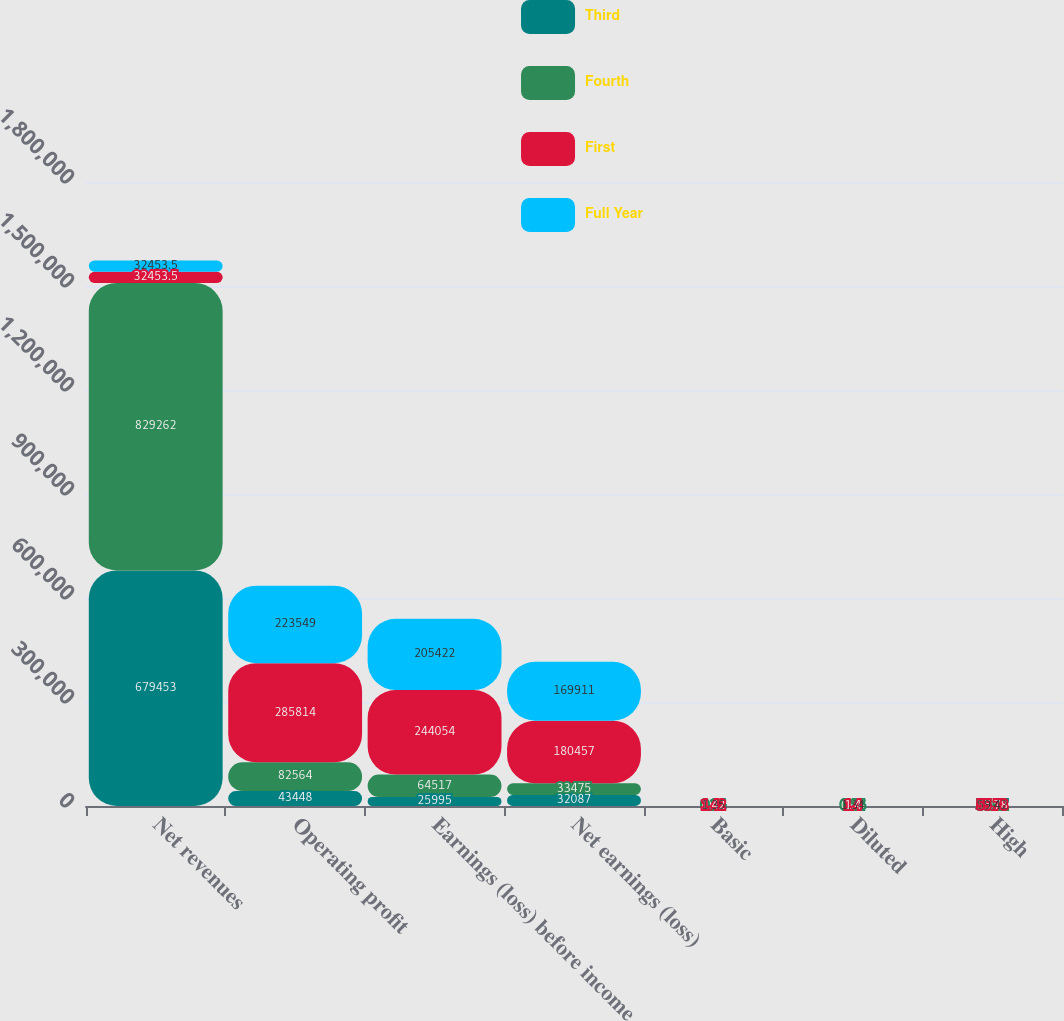<chart> <loc_0><loc_0><loc_500><loc_500><stacked_bar_chart><ecel><fcel>Net revenues<fcel>Operating profit<fcel>Earnings (loss) before income<fcel>Net earnings (loss)<fcel>Basic<fcel>Diluted<fcel>High<nl><fcel>Third<fcel>679453<fcel>43448<fcel>25995<fcel>32087<fcel>0.24<fcel>0.24<fcel>55.67<nl><fcel>Fourth<fcel>829262<fcel>82564<fcel>64517<fcel>33475<fcel>0.26<fcel>0.26<fcel>56.91<nl><fcel>First<fcel>32453.5<fcel>285814<fcel>244054<fcel>180457<fcel>1.42<fcel>1.4<fcel>55.78<nl><fcel>Full Year<fcel>32453.5<fcel>223549<fcel>205422<fcel>169911<fcel>1.35<fcel>1.34<fcel>59.42<nl></chart> 